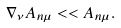<formula> <loc_0><loc_0><loc_500><loc_500>\nabla _ { \nu } A _ { n \mu } < < A _ { n \mu } .</formula> 